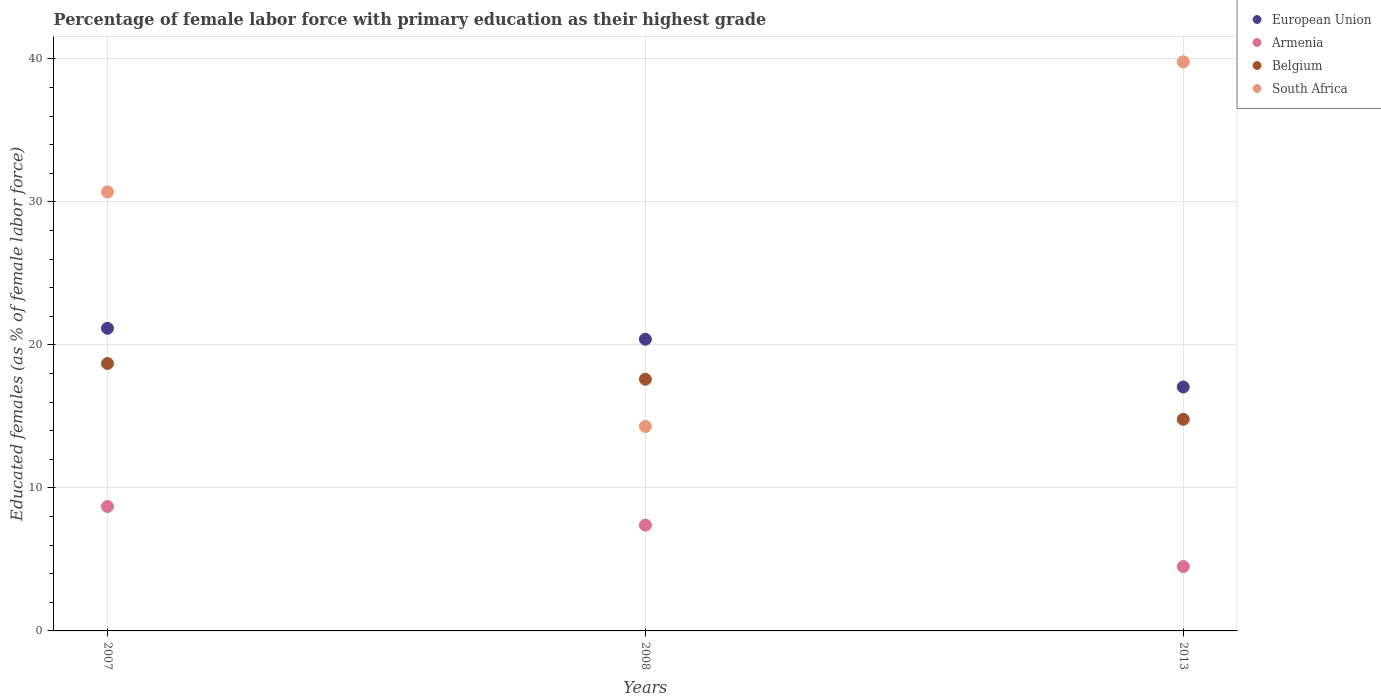Is the number of dotlines equal to the number of legend labels?
Ensure brevity in your answer.  Yes. What is the percentage of female labor force with primary education in South Africa in 2013?
Ensure brevity in your answer.  39.8. Across all years, what is the maximum percentage of female labor force with primary education in South Africa?
Offer a terse response. 39.8. Across all years, what is the minimum percentage of female labor force with primary education in European Union?
Your answer should be very brief. 17.06. In which year was the percentage of female labor force with primary education in European Union minimum?
Provide a short and direct response. 2013. What is the total percentage of female labor force with primary education in European Union in the graph?
Offer a terse response. 58.62. What is the difference between the percentage of female labor force with primary education in European Union in 2007 and that in 2008?
Provide a short and direct response. 0.76. What is the difference between the percentage of female labor force with primary education in South Africa in 2013 and the percentage of female labor force with primary education in Belgium in 2007?
Keep it short and to the point. 21.1. What is the average percentage of female labor force with primary education in European Union per year?
Your answer should be compact. 19.54. In the year 2008, what is the difference between the percentage of female labor force with primary education in Armenia and percentage of female labor force with primary education in South Africa?
Make the answer very short. -6.9. What is the ratio of the percentage of female labor force with primary education in South Africa in 2008 to that in 2013?
Ensure brevity in your answer.  0.36. Is the percentage of female labor force with primary education in Armenia in 2007 less than that in 2008?
Make the answer very short. No. Is the difference between the percentage of female labor force with primary education in Armenia in 2007 and 2013 greater than the difference between the percentage of female labor force with primary education in South Africa in 2007 and 2013?
Your response must be concise. Yes. What is the difference between the highest and the second highest percentage of female labor force with primary education in European Union?
Ensure brevity in your answer.  0.76. What is the difference between the highest and the lowest percentage of female labor force with primary education in South Africa?
Give a very brief answer. 25.5. In how many years, is the percentage of female labor force with primary education in Belgium greater than the average percentage of female labor force with primary education in Belgium taken over all years?
Give a very brief answer. 2. Is the sum of the percentage of female labor force with primary education in Armenia in 2007 and 2008 greater than the maximum percentage of female labor force with primary education in South Africa across all years?
Provide a short and direct response. No. Is it the case that in every year, the sum of the percentage of female labor force with primary education in European Union and percentage of female labor force with primary education in Belgium  is greater than the percentage of female labor force with primary education in South Africa?
Give a very brief answer. No. Does the percentage of female labor force with primary education in Belgium monotonically increase over the years?
Provide a short and direct response. No. Is the percentage of female labor force with primary education in South Africa strictly greater than the percentage of female labor force with primary education in European Union over the years?
Give a very brief answer. No. How many years are there in the graph?
Offer a terse response. 3. What is the difference between two consecutive major ticks on the Y-axis?
Ensure brevity in your answer.  10. Does the graph contain any zero values?
Give a very brief answer. No. Does the graph contain grids?
Give a very brief answer. Yes. How many legend labels are there?
Make the answer very short. 4. How are the legend labels stacked?
Provide a succinct answer. Vertical. What is the title of the graph?
Offer a very short reply. Percentage of female labor force with primary education as their highest grade. What is the label or title of the Y-axis?
Your answer should be very brief. Educated females (as % of female labor force). What is the Educated females (as % of female labor force) of European Union in 2007?
Give a very brief answer. 21.16. What is the Educated females (as % of female labor force) of Armenia in 2007?
Your answer should be compact. 8.7. What is the Educated females (as % of female labor force) in Belgium in 2007?
Ensure brevity in your answer.  18.7. What is the Educated females (as % of female labor force) of South Africa in 2007?
Keep it short and to the point. 30.7. What is the Educated females (as % of female labor force) in European Union in 2008?
Offer a terse response. 20.4. What is the Educated females (as % of female labor force) of Armenia in 2008?
Provide a succinct answer. 7.4. What is the Educated females (as % of female labor force) in Belgium in 2008?
Your answer should be compact. 17.6. What is the Educated females (as % of female labor force) in South Africa in 2008?
Offer a very short reply. 14.3. What is the Educated females (as % of female labor force) in European Union in 2013?
Offer a very short reply. 17.06. What is the Educated females (as % of female labor force) in Armenia in 2013?
Provide a short and direct response. 4.5. What is the Educated females (as % of female labor force) of Belgium in 2013?
Provide a short and direct response. 14.8. What is the Educated females (as % of female labor force) in South Africa in 2013?
Provide a succinct answer. 39.8. Across all years, what is the maximum Educated females (as % of female labor force) of European Union?
Give a very brief answer. 21.16. Across all years, what is the maximum Educated females (as % of female labor force) in Armenia?
Keep it short and to the point. 8.7. Across all years, what is the maximum Educated females (as % of female labor force) in Belgium?
Offer a terse response. 18.7. Across all years, what is the maximum Educated females (as % of female labor force) of South Africa?
Give a very brief answer. 39.8. Across all years, what is the minimum Educated females (as % of female labor force) of European Union?
Provide a short and direct response. 17.06. Across all years, what is the minimum Educated females (as % of female labor force) in Armenia?
Keep it short and to the point. 4.5. Across all years, what is the minimum Educated females (as % of female labor force) in Belgium?
Provide a short and direct response. 14.8. Across all years, what is the minimum Educated females (as % of female labor force) of South Africa?
Your answer should be compact. 14.3. What is the total Educated females (as % of female labor force) in European Union in the graph?
Give a very brief answer. 58.62. What is the total Educated females (as % of female labor force) in Armenia in the graph?
Offer a terse response. 20.6. What is the total Educated females (as % of female labor force) of Belgium in the graph?
Your response must be concise. 51.1. What is the total Educated females (as % of female labor force) of South Africa in the graph?
Keep it short and to the point. 84.8. What is the difference between the Educated females (as % of female labor force) of European Union in 2007 and that in 2008?
Offer a terse response. 0.76. What is the difference between the Educated females (as % of female labor force) of Armenia in 2007 and that in 2008?
Provide a short and direct response. 1.3. What is the difference between the Educated females (as % of female labor force) of South Africa in 2007 and that in 2008?
Keep it short and to the point. 16.4. What is the difference between the Educated females (as % of female labor force) of European Union in 2007 and that in 2013?
Keep it short and to the point. 4.11. What is the difference between the Educated females (as % of female labor force) of Belgium in 2007 and that in 2013?
Your answer should be compact. 3.9. What is the difference between the Educated females (as % of female labor force) in European Union in 2008 and that in 2013?
Provide a succinct answer. 3.34. What is the difference between the Educated females (as % of female labor force) of Armenia in 2008 and that in 2013?
Offer a very short reply. 2.9. What is the difference between the Educated females (as % of female labor force) of South Africa in 2008 and that in 2013?
Your response must be concise. -25.5. What is the difference between the Educated females (as % of female labor force) of European Union in 2007 and the Educated females (as % of female labor force) of Armenia in 2008?
Your answer should be compact. 13.76. What is the difference between the Educated females (as % of female labor force) of European Union in 2007 and the Educated females (as % of female labor force) of Belgium in 2008?
Your response must be concise. 3.56. What is the difference between the Educated females (as % of female labor force) of European Union in 2007 and the Educated females (as % of female labor force) of South Africa in 2008?
Offer a very short reply. 6.86. What is the difference between the Educated females (as % of female labor force) in Armenia in 2007 and the Educated females (as % of female labor force) in Belgium in 2008?
Your answer should be very brief. -8.9. What is the difference between the Educated females (as % of female labor force) of Armenia in 2007 and the Educated females (as % of female labor force) of South Africa in 2008?
Ensure brevity in your answer.  -5.6. What is the difference between the Educated females (as % of female labor force) of European Union in 2007 and the Educated females (as % of female labor force) of Armenia in 2013?
Provide a succinct answer. 16.66. What is the difference between the Educated females (as % of female labor force) in European Union in 2007 and the Educated females (as % of female labor force) in Belgium in 2013?
Your answer should be compact. 6.36. What is the difference between the Educated females (as % of female labor force) in European Union in 2007 and the Educated females (as % of female labor force) in South Africa in 2013?
Provide a short and direct response. -18.64. What is the difference between the Educated females (as % of female labor force) in Armenia in 2007 and the Educated females (as % of female labor force) in South Africa in 2013?
Give a very brief answer. -31.1. What is the difference between the Educated females (as % of female labor force) in Belgium in 2007 and the Educated females (as % of female labor force) in South Africa in 2013?
Give a very brief answer. -21.1. What is the difference between the Educated females (as % of female labor force) of European Union in 2008 and the Educated females (as % of female labor force) of Armenia in 2013?
Your answer should be compact. 15.9. What is the difference between the Educated females (as % of female labor force) of European Union in 2008 and the Educated females (as % of female labor force) of Belgium in 2013?
Your answer should be very brief. 5.6. What is the difference between the Educated females (as % of female labor force) in European Union in 2008 and the Educated females (as % of female labor force) in South Africa in 2013?
Your answer should be very brief. -19.4. What is the difference between the Educated females (as % of female labor force) of Armenia in 2008 and the Educated females (as % of female labor force) of South Africa in 2013?
Give a very brief answer. -32.4. What is the difference between the Educated females (as % of female labor force) in Belgium in 2008 and the Educated females (as % of female labor force) in South Africa in 2013?
Offer a very short reply. -22.2. What is the average Educated females (as % of female labor force) of European Union per year?
Provide a short and direct response. 19.54. What is the average Educated females (as % of female labor force) in Armenia per year?
Make the answer very short. 6.87. What is the average Educated females (as % of female labor force) of Belgium per year?
Give a very brief answer. 17.03. What is the average Educated females (as % of female labor force) of South Africa per year?
Provide a succinct answer. 28.27. In the year 2007, what is the difference between the Educated females (as % of female labor force) of European Union and Educated females (as % of female labor force) of Armenia?
Your response must be concise. 12.46. In the year 2007, what is the difference between the Educated females (as % of female labor force) in European Union and Educated females (as % of female labor force) in Belgium?
Your answer should be very brief. 2.46. In the year 2007, what is the difference between the Educated females (as % of female labor force) of European Union and Educated females (as % of female labor force) of South Africa?
Provide a succinct answer. -9.54. In the year 2008, what is the difference between the Educated females (as % of female labor force) of European Union and Educated females (as % of female labor force) of Armenia?
Your answer should be very brief. 13. In the year 2008, what is the difference between the Educated females (as % of female labor force) of European Union and Educated females (as % of female labor force) of Belgium?
Keep it short and to the point. 2.8. In the year 2008, what is the difference between the Educated females (as % of female labor force) of European Union and Educated females (as % of female labor force) of South Africa?
Offer a very short reply. 6.1. In the year 2008, what is the difference between the Educated females (as % of female labor force) in Belgium and Educated females (as % of female labor force) in South Africa?
Your answer should be very brief. 3.3. In the year 2013, what is the difference between the Educated females (as % of female labor force) of European Union and Educated females (as % of female labor force) of Armenia?
Make the answer very short. 12.56. In the year 2013, what is the difference between the Educated females (as % of female labor force) of European Union and Educated females (as % of female labor force) of Belgium?
Provide a short and direct response. 2.26. In the year 2013, what is the difference between the Educated females (as % of female labor force) of European Union and Educated females (as % of female labor force) of South Africa?
Provide a succinct answer. -22.74. In the year 2013, what is the difference between the Educated females (as % of female labor force) of Armenia and Educated females (as % of female labor force) of South Africa?
Offer a very short reply. -35.3. What is the ratio of the Educated females (as % of female labor force) in European Union in 2007 to that in 2008?
Offer a very short reply. 1.04. What is the ratio of the Educated females (as % of female labor force) in Armenia in 2007 to that in 2008?
Keep it short and to the point. 1.18. What is the ratio of the Educated females (as % of female labor force) of Belgium in 2007 to that in 2008?
Provide a succinct answer. 1.06. What is the ratio of the Educated females (as % of female labor force) of South Africa in 2007 to that in 2008?
Your response must be concise. 2.15. What is the ratio of the Educated females (as % of female labor force) of European Union in 2007 to that in 2013?
Your answer should be compact. 1.24. What is the ratio of the Educated females (as % of female labor force) in Armenia in 2007 to that in 2013?
Offer a terse response. 1.93. What is the ratio of the Educated females (as % of female labor force) of Belgium in 2007 to that in 2013?
Provide a succinct answer. 1.26. What is the ratio of the Educated females (as % of female labor force) of South Africa in 2007 to that in 2013?
Your response must be concise. 0.77. What is the ratio of the Educated females (as % of female labor force) of European Union in 2008 to that in 2013?
Keep it short and to the point. 1.2. What is the ratio of the Educated females (as % of female labor force) in Armenia in 2008 to that in 2013?
Keep it short and to the point. 1.64. What is the ratio of the Educated females (as % of female labor force) of Belgium in 2008 to that in 2013?
Make the answer very short. 1.19. What is the ratio of the Educated females (as % of female labor force) of South Africa in 2008 to that in 2013?
Offer a very short reply. 0.36. What is the difference between the highest and the second highest Educated females (as % of female labor force) of European Union?
Give a very brief answer. 0.76. What is the difference between the highest and the second highest Educated females (as % of female labor force) in Armenia?
Your response must be concise. 1.3. What is the difference between the highest and the second highest Educated females (as % of female labor force) of South Africa?
Ensure brevity in your answer.  9.1. What is the difference between the highest and the lowest Educated females (as % of female labor force) in European Union?
Your answer should be very brief. 4.11. What is the difference between the highest and the lowest Educated females (as % of female labor force) in Armenia?
Provide a short and direct response. 4.2. What is the difference between the highest and the lowest Educated females (as % of female labor force) in Belgium?
Offer a terse response. 3.9. 